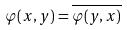Convert formula to latex. <formula><loc_0><loc_0><loc_500><loc_500>\varphi ( x , y ) = \overline { \varphi ( y , x ) }</formula> 